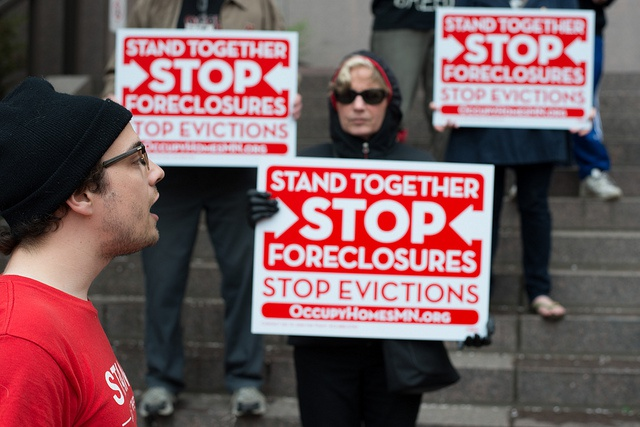Describe the objects in this image and their specific colors. I can see people in black, brown, and gray tones, stop sign in black, lavender, red, lightpink, and salmon tones, people in black, gray, and darkgray tones, stop sign in black, lightgray, lightpink, red, and pink tones, and people in black, gray, and maroon tones in this image. 